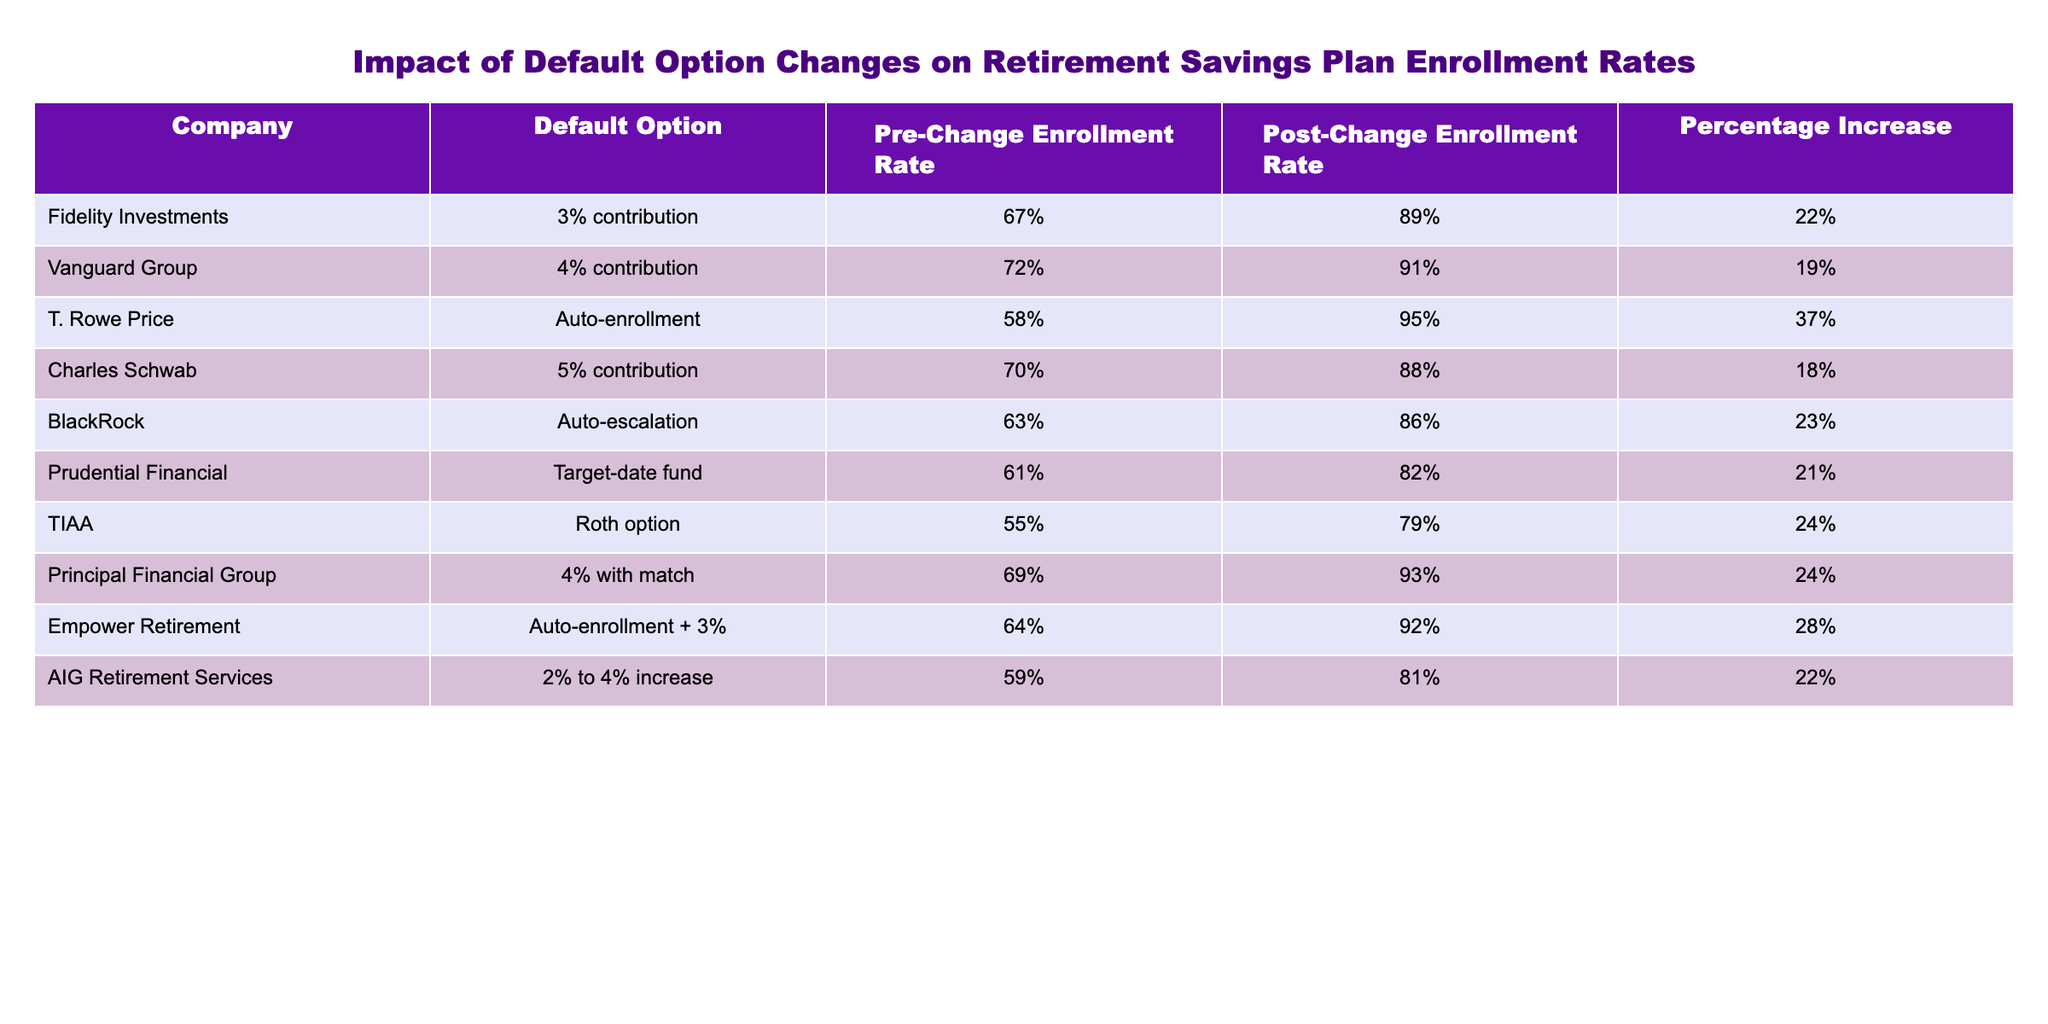What is the highest post-change enrollment rate? The table lists the post-change enrollment rates for each company. The highest value is 95%, achieved by T. Rowe Price.
Answer: 95% Which company showed the largest percentage increase in enrollment rates? To find the largest percentage increase, we compare the "Percentage Increase" column values. T. Rowe Price has the highest increase at 37%.
Answer: 37% What was the pre-change enrollment rate for Vanguard Group? The pre-change enrollment rate for Vanguard Group is listed as 72%.
Answer: 72% Is the post-change enrollment rate for Charles Schwab higher than 90%? Checking the post-change enrollment rate for Charles Schwab reveals it is 88%, which is not higher than 90%.
Answer: No What is the average percentage increase across all companies listed? To find the average percentage increase, add all values in the "Percentage Increase" column and divide by the number of companies: (22 + 19 + 37 + 18 + 23 + 21 + 24 + 24 + 28 + 22)/10 = 23.8%.
Answer: 23.8% Which companies had a post-change enrollment rate below 85%? We check the post-change enrollment rates for each company. From the table, Charles Schwab (88%) and AIG Retirement Services (81%) are below 85%.
Answer: Charles Schwab and AIG Retirement Services How many companies had a pre-change enrollment rate greater than 60%? By reviewing the "Pre-Change Enrollment Rate" column, the rates greater than 60% are Fidelity Investments, Vanguard Group, Charles Schwab, BlackRock, Prudential Financial, and Principal Financial Group. This totals six companies.
Answer: 6 What is the difference between the highest and lowest pre-change enrollment rates? The highest pre-change enrollment rate is 72% (Vanguard Group) and the lowest is 55% (TIAA). Thus, the difference is 72% - 55% = 17%.
Answer: 17% Which companies utilized auto-enrollment as a default option? Looking at the "Default Option" column, T. Rowe Price and Empower Retirement both listed auto-enrollment as their default option.
Answer: T. Rowe Price and Empower Retirement What percentage of the companies listed had a post-change enrollment rate of 90% or higher? There are 10 companies listed. Out of those, T. Rowe Price (95%), Vanguard Group (91%), Principal Financial Group (93%), and Empower Retirement (92%) all have post-change enrollment rates of 90% or higher, which is 4 out of 10 companies or 40%.
Answer: 40% 